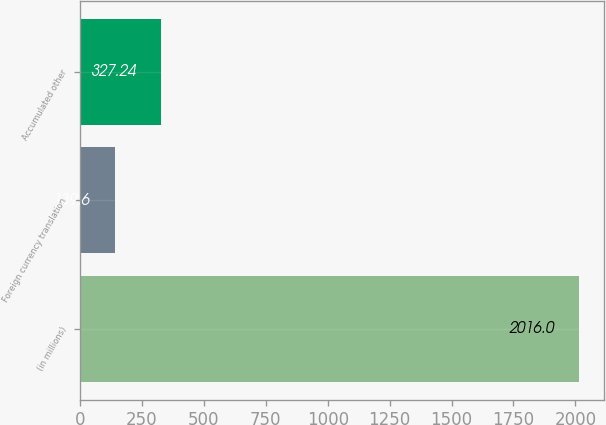Convert chart. <chart><loc_0><loc_0><loc_500><loc_500><bar_chart><fcel>(in millions)<fcel>Foreign currency translation<fcel>Accumulated other<nl><fcel>2016<fcel>139.6<fcel>327.24<nl></chart> 